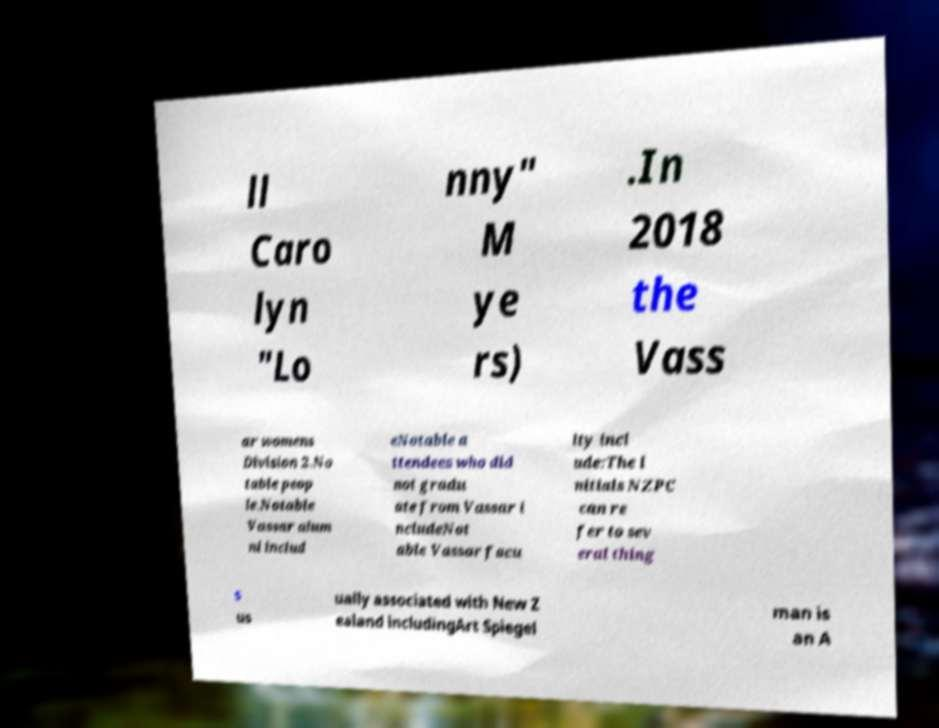There's text embedded in this image that I need extracted. Can you transcribe it verbatim? ll Caro lyn "Lo nny" M ye rs) .In 2018 the Vass ar womens Division 2.No table peop le.Notable Vassar alum ni includ eNotable a ttendees who did not gradu ate from Vassar i ncludeNot able Vassar facu lty incl ude:The i nitials NZPC can re fer to sev eral thing s us ually associated with New Z ealand includingArt Spiegel man is an A 